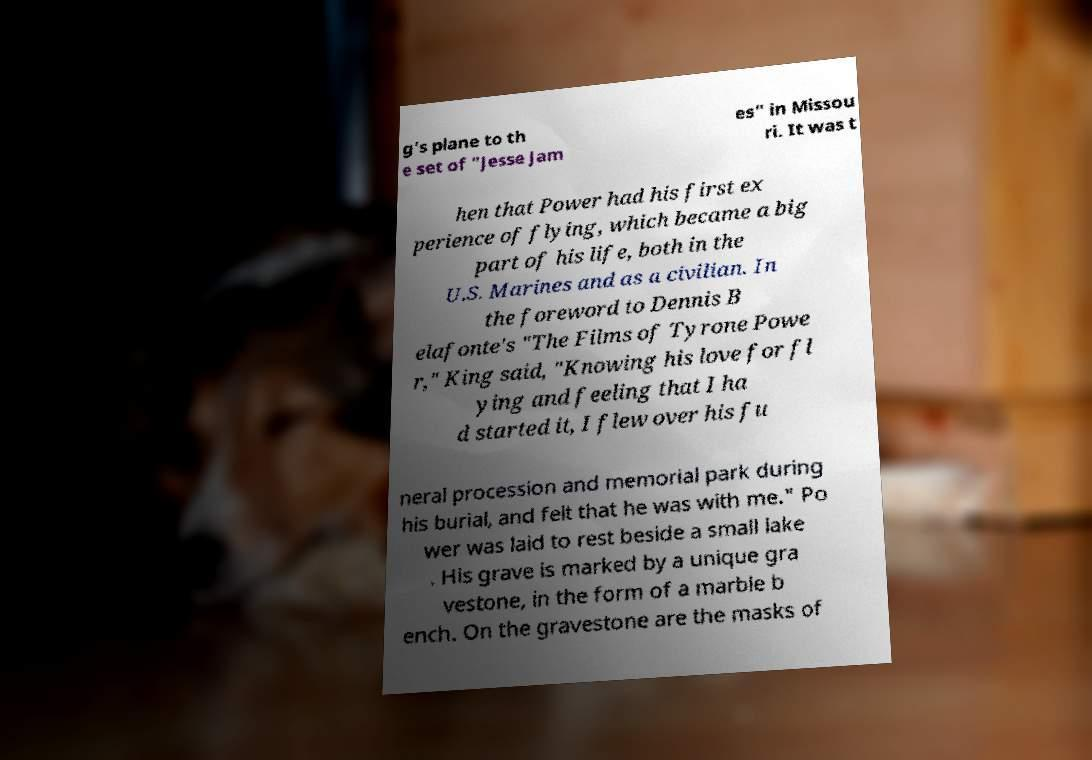Can you accurately transcribe the text from the provided image for me? g's plane to th e set of "Jesse Jam es" in Missou ri. It was t hen that Power had his first ex perience of flying, which became a big part of his life, both in the U.S. Marines and as a civilian. In the foreword to Dennis B elafonte's "The Films of Tyrone Powe r," King said, "Knowing his love for fl ying and feeling that I ha d started it, I flew over his fu neral procession and memorial park during his burial, and felt that he was with me." Po wer was laid to rest beside a small lake . His grave is marked by a unique gra vestone, in the form of a marble b ench. On the gravestone are the masks of 